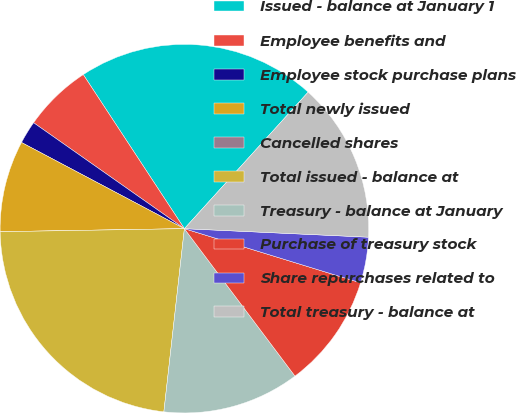Convert chart to OTSL. <chart><loc_0><loc_0><loc_500><loc_500><pie_chart><fcel>Issued - balance at January 1<fcel>Employee benefits and<fcel>Employee stock purchase plans<fcel>Total newly issued<fcel>Cancelled shares<fcel>Total issued - balance at<fcel>Treasury - balance at January<fcel>Purchase of treasury stock<fcel>Share repurchases related to<fcel>Total treasury - balance at<nl><fcel>20.96%<fcel>6.01%<fcel>2.0%<fcel>8.01%<fcel>0.0%<fcel>22.96%<fcel>12.02%<fcel>10.01%<fcel>4.01%<fcel>14.02%<nl></chart> 